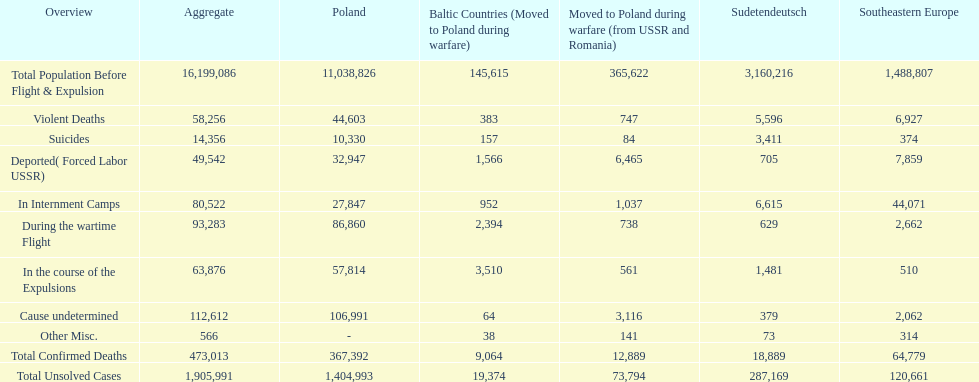What is the total of deaths in internment camps and during the wartime flight? 173,805. 